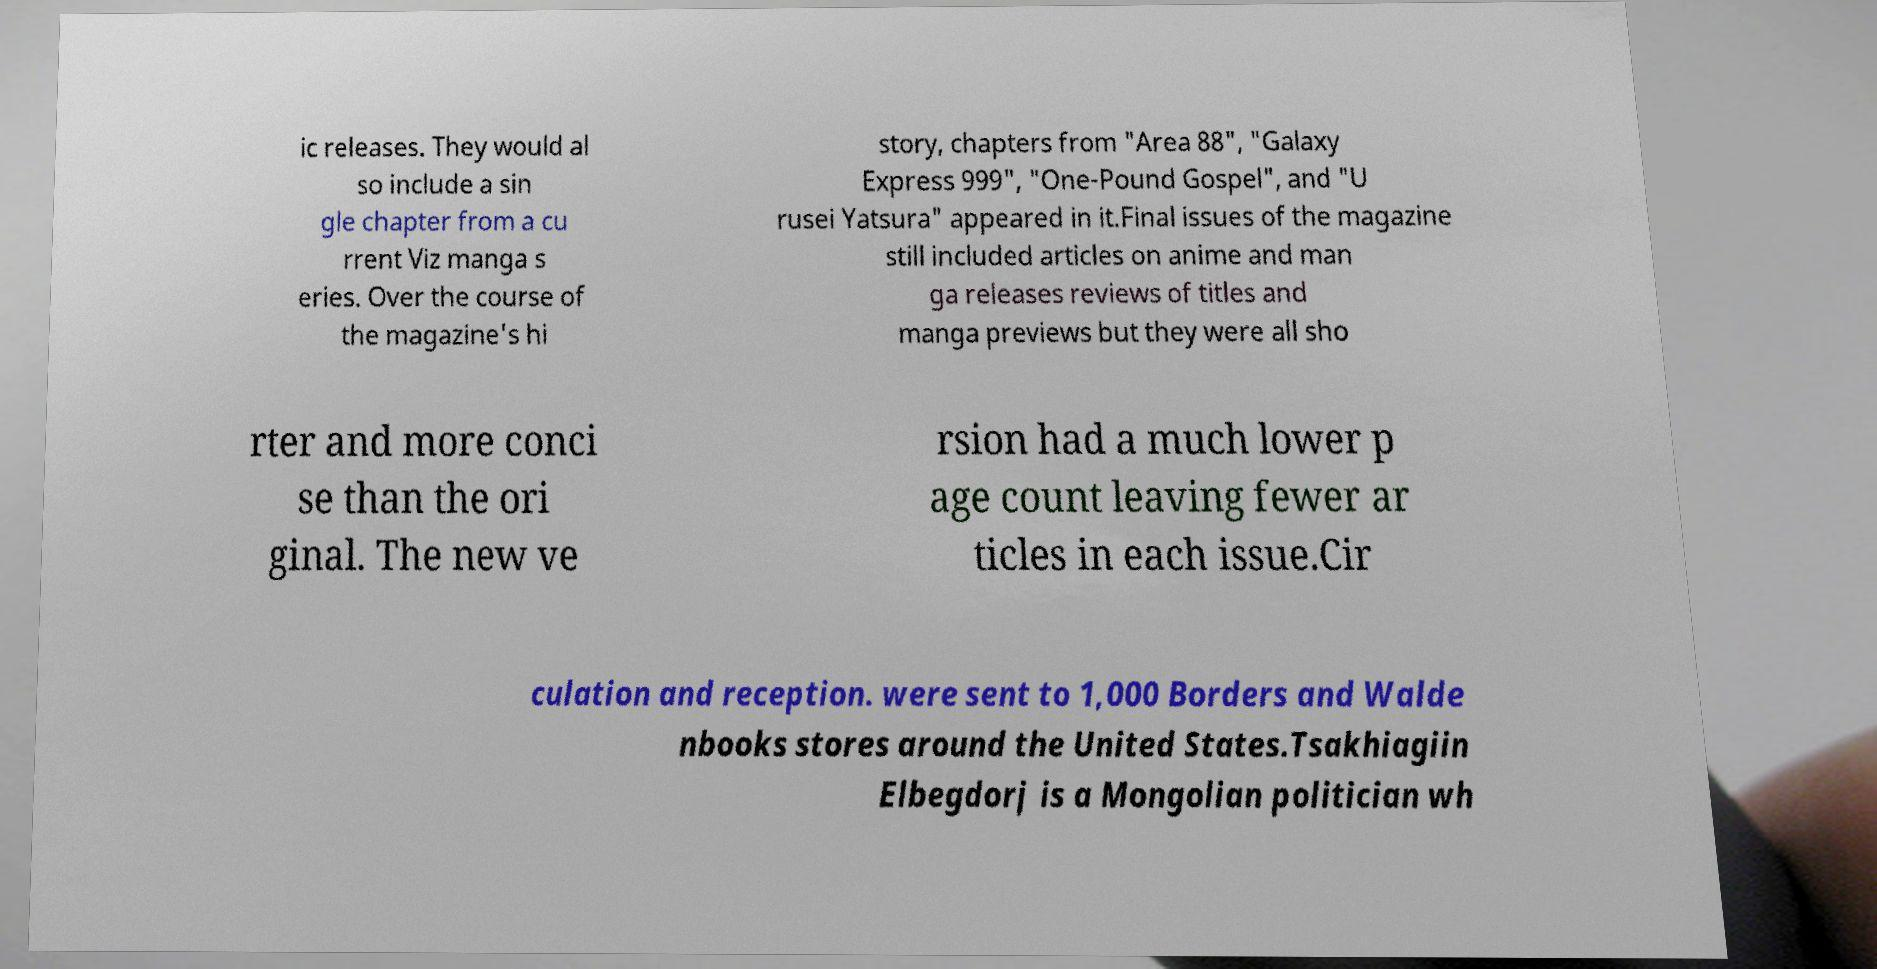I need the written content from this picture converted into text. Can you do that? ic releases. They would al so include a sin gle chapter from a cu rrent Viz manga s eries. Over the course of the magazine's hi story, chapters from "Area 88", "Galaxy Express 999", "One-Pound Gospel", and "U rusei Yatsura" appeared in it.Final issues of the magazine still included articles on anime and man ga releases reviews of titles and manga previews but they were all sho rter and more conci se than the ori ginal. The new ve rsion had a much lower p age count leaving fewer ar ticles in each issue.Cir culation and reception. were sent to 1,000 Borders and Walde nbooks stores around the United States.Tsakhiagiin Elbegdorj is a Mongolian politician wh 